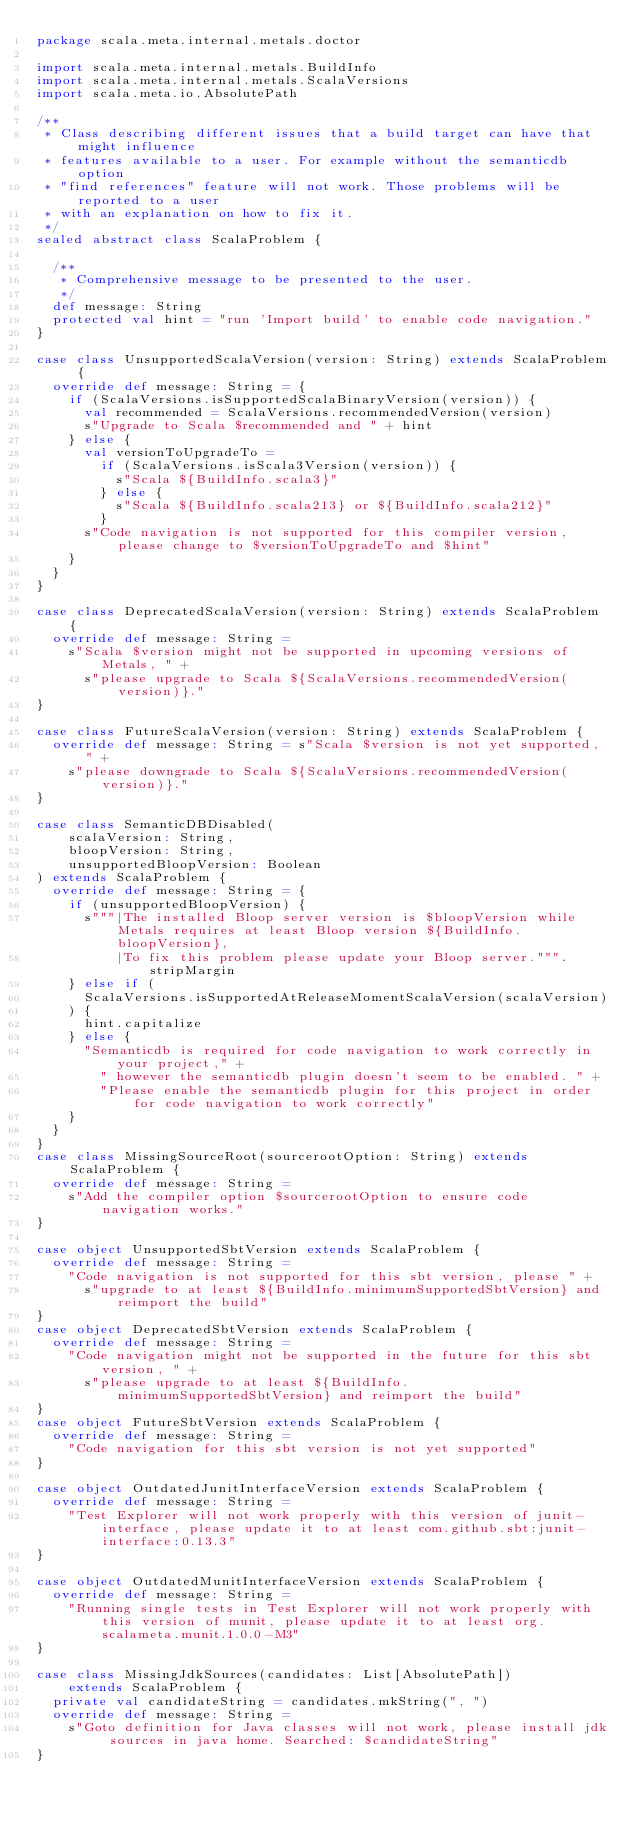Convert code to text. <code><loc_0><loc_0><loc_500><loc_500><_Scala_>package scala.meta.internal.metals.doctor

import scala.meta.internal.metals.BuildInfo
import scala.meta.internal.metals.ScalaVersions
import scala.meta.io.AbsolutePath

/**
 * Class describing different issues that a build target can have that might influence
 * features available to a user. For example without the semanticdb option
 * "find references" feature will not work. Those problems will be reported to a user
 * with an explanation on how to fix it.
 */
sealed abstract class ScalaProblem {

  /**
   * Comprehensive message to be presented to the user.
   */
  def message: String
  protected val hint = "run 'Import build' to enable code navigation."
}

case class UnsupportedScalaVersion(version: String) extends ScalaProblem {
  override def message: String = {
    if (ScalaVersions.isSupportedScalaBinaryVersion(version)) {
      val recommended = ScalaVersions.recommendedVersion(version)
      s"Upgrade to Scala $recommended and " + hint
    } else {
      val versionToUpgradeTo =
        if (ScalaVersions.isScala3Version(version)) {
          s"Scala ${BuildInfo.scala3}"
        } else {
          s"Scala ${BuildInfo.scala213} or ${BuildInfo.scala212}"
        }
      s"Code navigation is not supported for this compiler version, please change to $versionToUpgradeTo and $hint"
    }
  }
}

case class DeprecatedScalaVersion(version: String) extends ScalaProblem {
  override def message: String =
    s"Scala $version might not be supported in upcoming versions of Metals, " +
      s"please upgrade to Scala ${ScalaVersions.recommendedVersion(version)}."
}

case class FutureScalaVersion(version: String) extends ScalaProblem {
  override def message: String = s"Scala $version is not yet supported, " +
    s"please downgrade to Scala ${ScalaVersions.recommendedVersion(version)}."
}

case class SemanticDBDisabled(
    scalaVersion: String,
    bloopVersion: String,
    unsupportedBloopVersion: Boolean
) extends ScalaProblem {
  override def message: String = {
    if (unsupportedBloopVersion) {
      s"""|The installed Bloop server version is $bloopVersion while Metals requires at least Bloop version ${BuildInfo.bloopVersion},
          |To fix this problem please update your Bloop server.""".stripMargin
    } else if (
      ScalaVersions.isSupportedAtReleaseMomentScalaVersion(scalaVersion)
    ) {
      hint.capitalize
    } else {
      "Semanticdb is required for code navigation to work correctly in your project," +
        " however the semanticdb plugin doesn't seem to be enabled. " +
        "Please enable the semanticdb plugin for this project in order for code navigation to work correctly"
    }
  }
}
case class MissingSourceRoot(sourcerootOption: String) extends ScalaProblem {
  override def message: String =
    s"Add the compiler option $sourcerootOption to ensure code navigation works."
}

case object UnsupportedSbtVersion extends ScalaProblem {
  override def message: String =
    "Code navigation is not supported for this sbt version, please " +
      s"upgrade to at least ${BuildInfo.minimumSupportedSbtVersion} and reimport the build"
}
case object DeprecatedSbtVersion extends ScalaProblem {
  override def message: String =
    "Code navigation might not be supported in the future for this sbt version, " +
      s"please upgrade to at least ${BuildInfo.minimumSupportedSbtVersion} and reimport the build"
}
case object FutureSbtVersion extends ScalaProblem {
  override def message: String =
    "Code navigation for this sbt version is not yet supported"
}

case object OutdatedJunitInterfaceVersion extends ScalaProblem {
  override def message: String =
    "Test Explorer will not work properly with this version of junit-interface, please update it to at least com.github.sbt:junit-interface:0.13.3"
}

case object OutdatedMunitInterfaceVersion extends ScalaProblem {
  override def message: String =
    "Running single tests in Test Explorer will not work properly with this version of munit, please update it to at least org.scalameta.munit.1.0.0-M3"
}

case class MissingJdkSources(candidates: List[AbsolutePath])
    extends ScalaProblem {
  private val candidateString = candidates.mkString(", ")
  override def message: String =
    s"Goto definition for Java classes will not work, please install jdk sources in java home. Searched: $candidateString"
}
</code> 